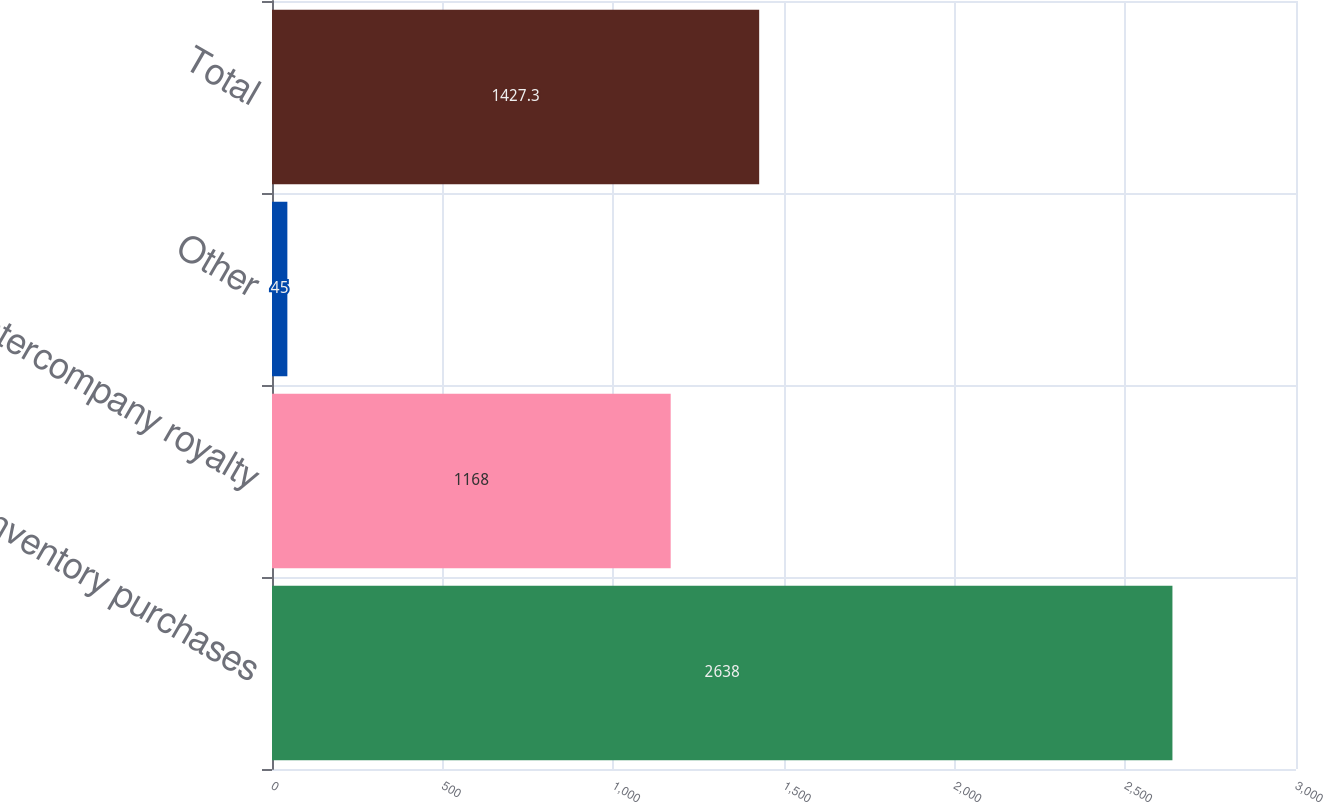<chart> <loc_0><loc_0><loc_500><loc_500><bar_chart><fcel>Inventory purchases<fcel>Intercompany royalty<fcel>Other<fcel>Total<nl><fcel>2638<fcel>1168<fcel>45<fcel>1427.3<nl></chart> 